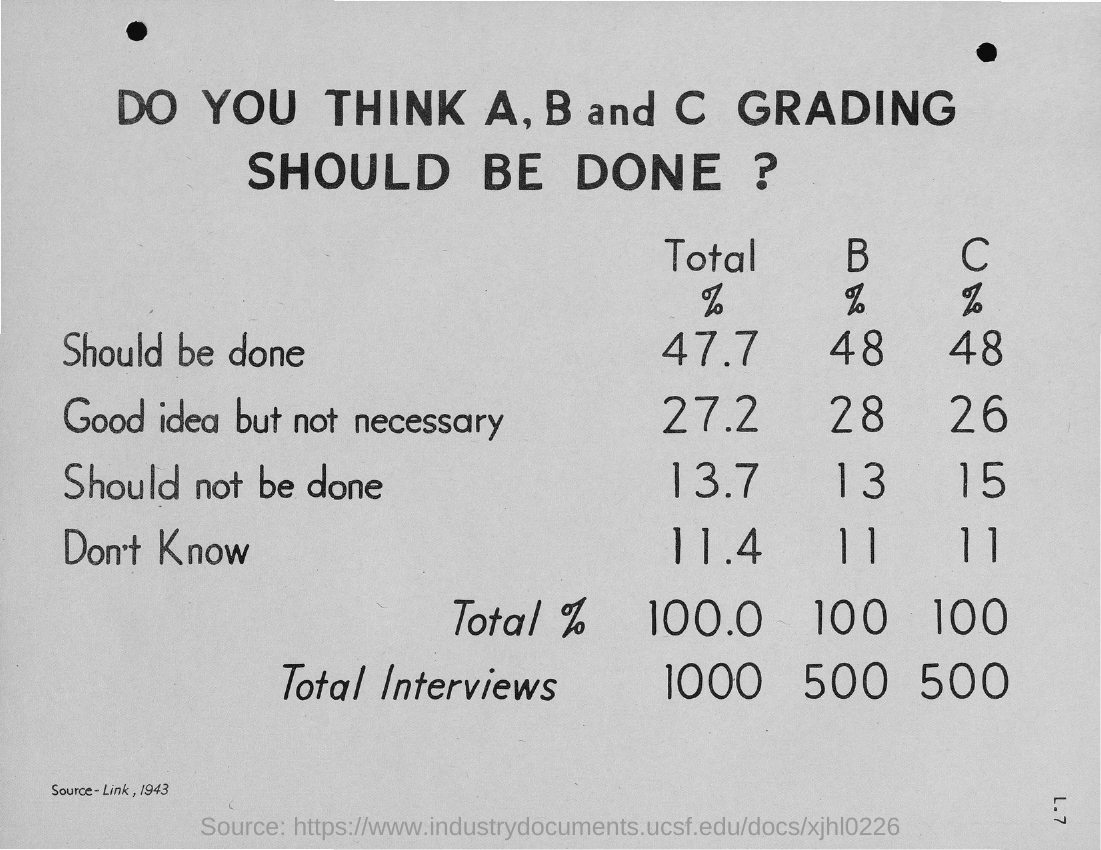What is the percentage of "Should be done" in the case of B grade?
Ensure brevity in your answer.  48. What is the percentage of "Should not be done" in the case of C grade?
Provide a succinct answer. 15. What is the percentage of "Good idea but not necessary" in the case of B grade?
Give a very brief answer. 28. What is the percentage of "Don't Know" in the case of C grade?
Your answer should be compact. 11. 